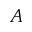<formula> <loc_0><loc_0><loc_500><loc_500>A</formula> 